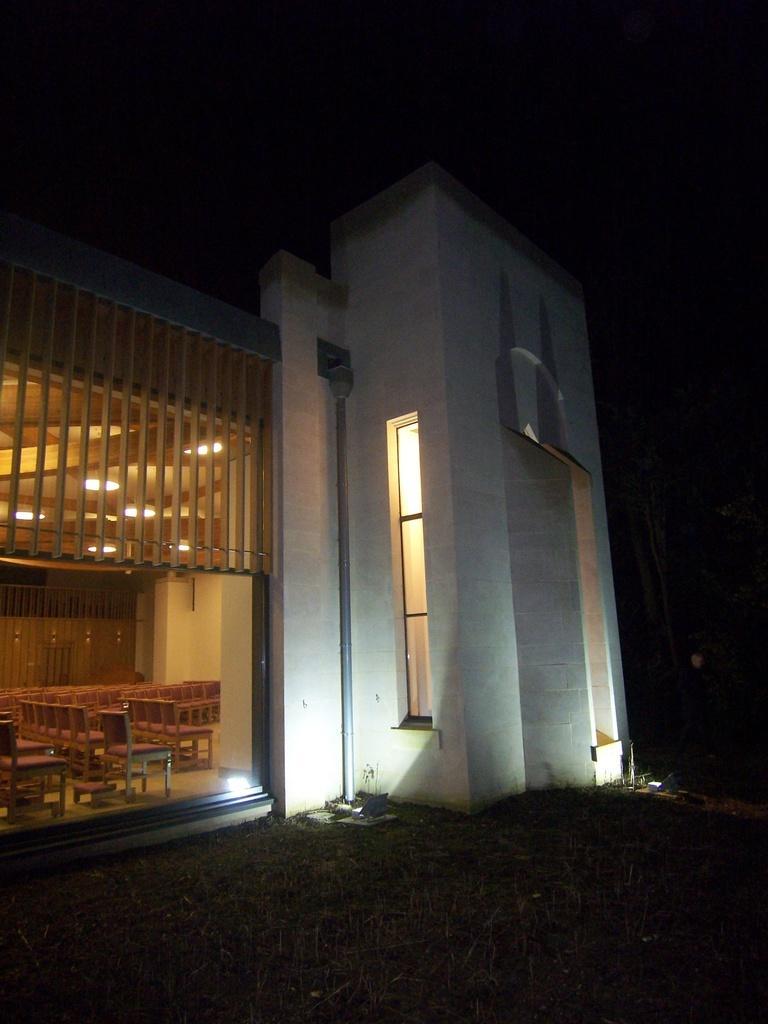Please provide a concise description of this image. In the picture I can see a building which has few chairs in the left corner and there are few lights above it. 